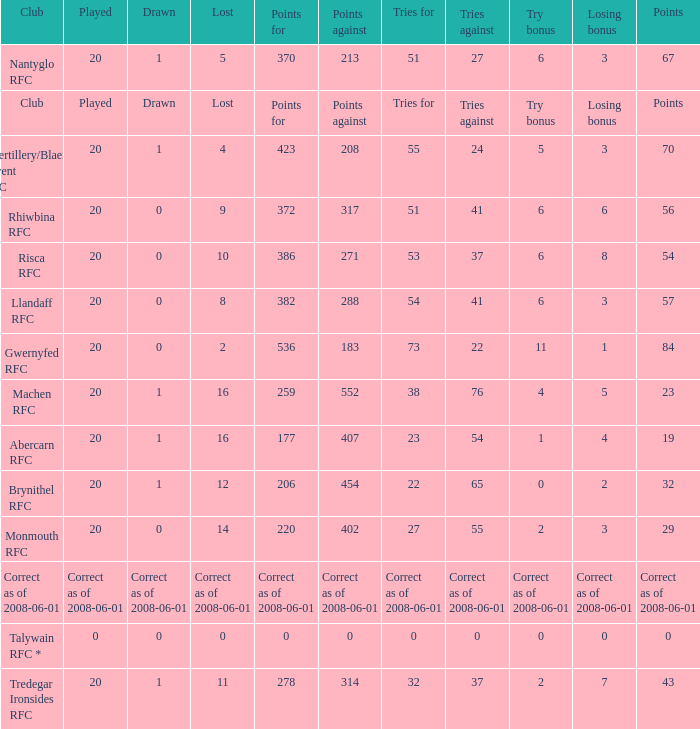Write the full table. {'header': ['Club', 'Played', 'Drawn', 'Lost', 'Points for', 'Points against', 'Tries for', 'Tries against', 'Try bonus', 'Losing bonus', 'Points'], 'rows': [['Nantyglo RFC', '20', '1', '5', '370', '213', '51', '27', '6', '3', '67'], ['Club', 'Played', 'Drawn', 'Lost', 'Points for', 'Points against', 'Tries for', 'Tries against', 'Try bonus', 'Losing bonus', 'Points'], ['Abertillery/Blaenau Gwent RFC', '20', '1', '4', '423', '208', '55', '24', '5', '3', '70'], ['Rhiwbina RFC', '20', '0', '9', '372', '317', '51', '41', '6', '6', '56'], ['Risca RFC', '20', '0', '10', '386', '271', '53', '37', '6', '8', '54'], ['Llandaff RFC', '20', '0', '8', '382', '288', '54', '41', '6', '3', '57'], ['Gwernyfed RFC', '20', '0', '2', '536', '183', '73', '22', '11', '1', '84'], ['Machen RFC', '20', '1', '16', '259', '552', '38', '76', '4', '5', '23'], ['Abercarn RFC', '20', '1', '16', '177', '407', '23', '54', '1', '4', '19'], ['Brynithel RFC', '20', '1', '12', '206', '454', '22', '65', '0', '2', '32'], ['Monmouth RFC', '20', '0', '14', '220', '402', '27', '55', '2', '3', '29'], ['Correct as of 2008-06-01', 'Correct as of 2008-06-01', 'Correct as of 2008-06-01', 'Correct as of 2008-06-01', 'Correct as of 2008-06-01', 'Correct as of 2008-06-01', 'Correct as of 2008-06-01', 'Correct as of 2008-06-01', 'Correct as of 2008-06-01', 'Correct as of 2008-06-01', 'Correct as of 2008-06-01'], ['Talywain RFC *', '0', '0', '0', '0', '0', '0', '0', '0', '0', '0'], ['Tredegar Ironsides RFC', '20', '1', '11', '278', '314', '32', '37', '2', '7', '43']]} What's the try bonus that had 423 points? 5.0. 